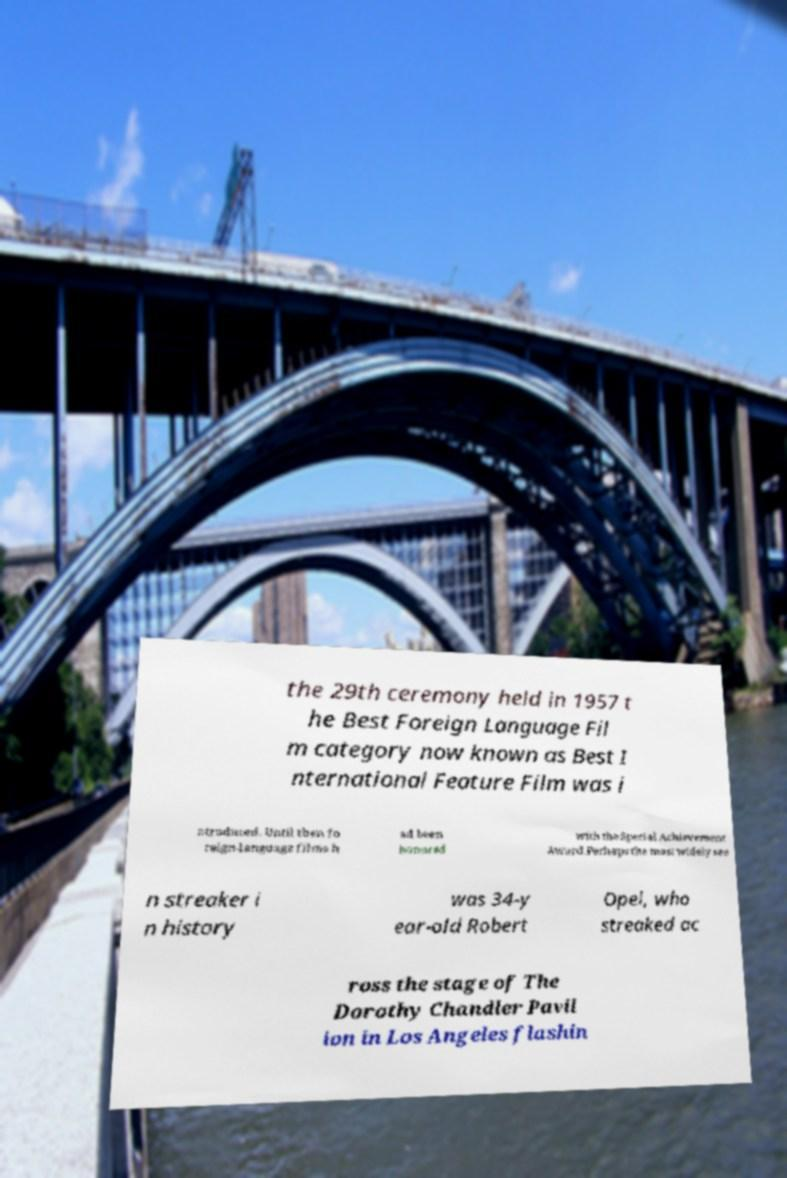Could you assist in decoding the text presented in this image and type it out clearly? the 29th ceremony held in 1957 t he Best Foreign Language Fil m category now known as Best I nternational Feature Film was i ntroduced. Until then fo reign-language films h ad been honored with the Special Achievement Award.Perhaps the most widely see n streaker i n history was 34-y ear-old Robert Opel, who streaked ac ross the stage of The Dorothy Chandler Pavil ion in Los Angeles flashin 